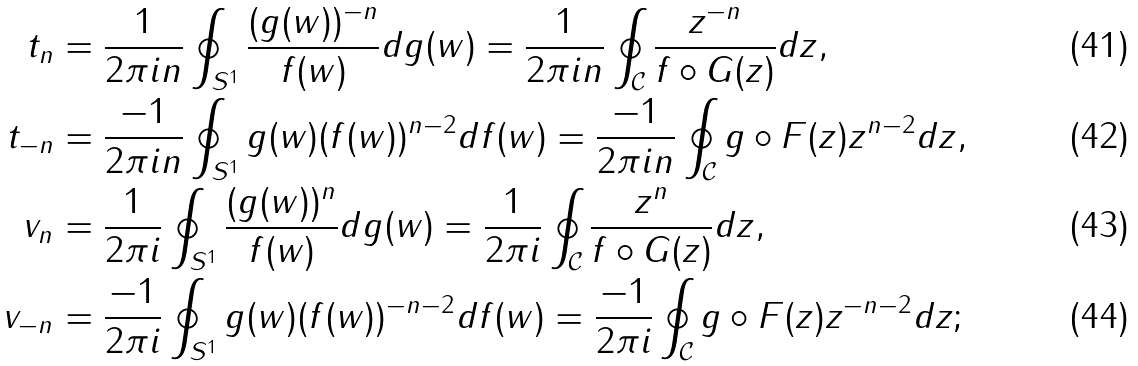<formula> <loc_0><loc_0><loc_500><loc_500>t _ { n } & = \frac { 1 } { 2 \pi i n } \oint _ { S ^ { 1 } } \frac { ( g ( w ) ) ^ { - n } } { f ( w ) } d g ( w ) = \frac { 1 } { 2 \pi i n } \oint _ { \mathcal { C } } \frac { z ^ { - n } } { f \circ G ( z ) } d z , \\ t _ { - n } & = \frac { - 1 } { 2 \pi i n } \oint _ { S ^ { 1 } } g ( w ) ( f ( w ) ) ^ { n - 2 } d f ( w ) = \frac { - 1 } { 2 \pi i n } \oint _ { \mathcal { C } } g \circ F ( z ) z ^ { n - 2 } d z , \\ v _ { n } & = \frac { 1 } { 2 \pi i } \oint _ { S ^ { 1 } } \frac { ( g ( w ) ) ^ { n } } { f ( w ) } d g ( w ) = \frac { 1 } { 2 \pi i } \oint _ { \mathcal { C } } \frac { z ^ { n } } { f \circ G ( z ) } d z , \\ v _ { - n } & = \frac { - 1 } { 2 \pi i } \oint _ { S ^ { 1 } } g ( w ) ( f ( w ) ) ^ { - n - 2 } d f ( w ) = \frac { - 1 } { 2 \pi i } \oint _ { \mathcal { C } } g \circ F ( z ) z ^ { - n - 2 } d z ;</formula> 